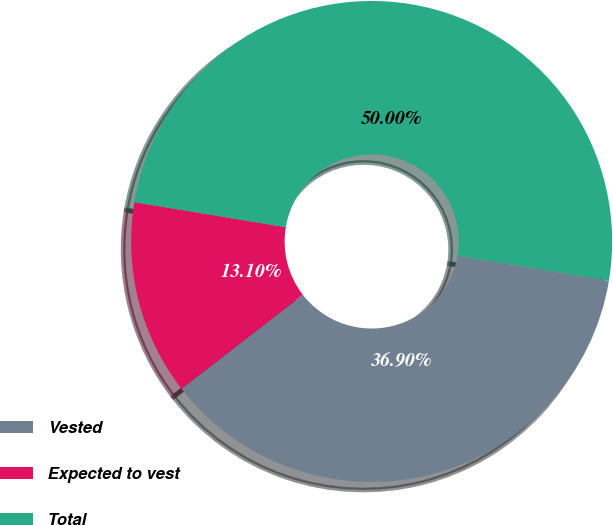<chart> <loc_0><loc_0><loc_500><loc_500><pie_chart><fcel>Vested<fcel>Expected to vest<fcel>Total<nl><fcel>36.9%<fcel>13.1%<fcel>50.0%<nl></chart> 